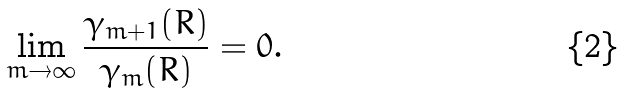Convert formula to latex. <formula><loc_0><loc_0><loc_500><loc_500>\lim _ { m \to \infty } \frac { \gamma _ { m + 1 } ( R ) } { \gamma _ { m } ( R ) } = 0 .</formula> 